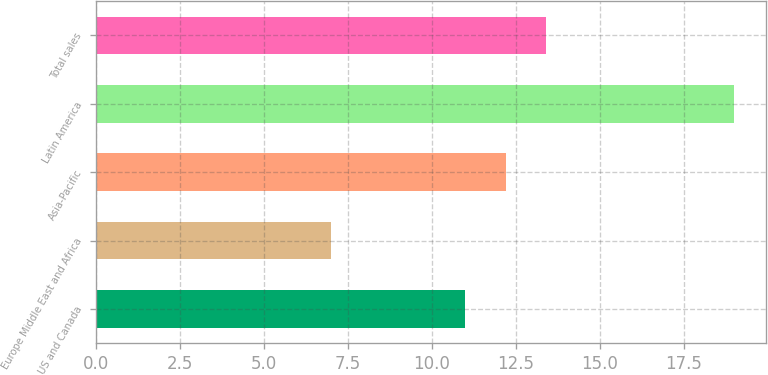Convert chart. <chart><loc_0><loc_0><loc_500><loc_500><bar_chart><fcel>US and Canada<fcel>Europe Middle East and Africa<fcel>Asia-Pacific<fcel>Latin America<fcel>Total sales<nl><fcel>11<fcel>7<fcel>12.2<fcel>19<fcel>13.4<nl></chart> 